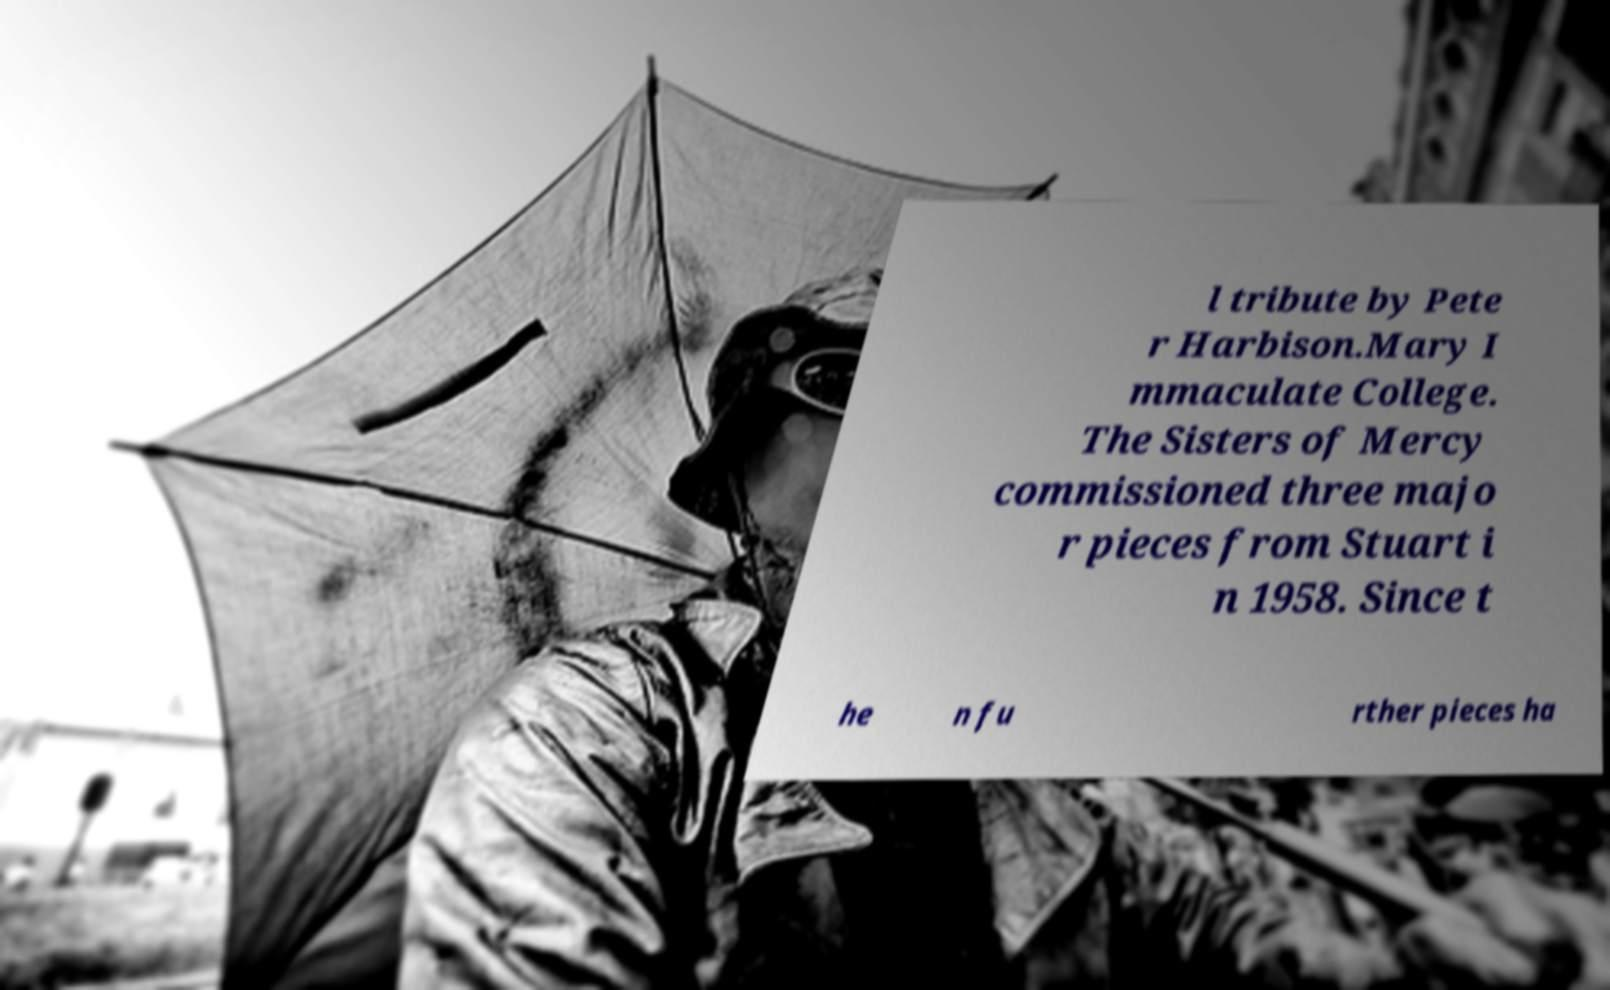There's text embedded in this image that I need extracted. Can you transcribe it verbatim? l tribute by Pete r Harbison.Mary I mmaculate College. The Sisters of Mercy commissioned three majo r pieces from Stuart i n 1958. Since t he n fu rther pieces ha 